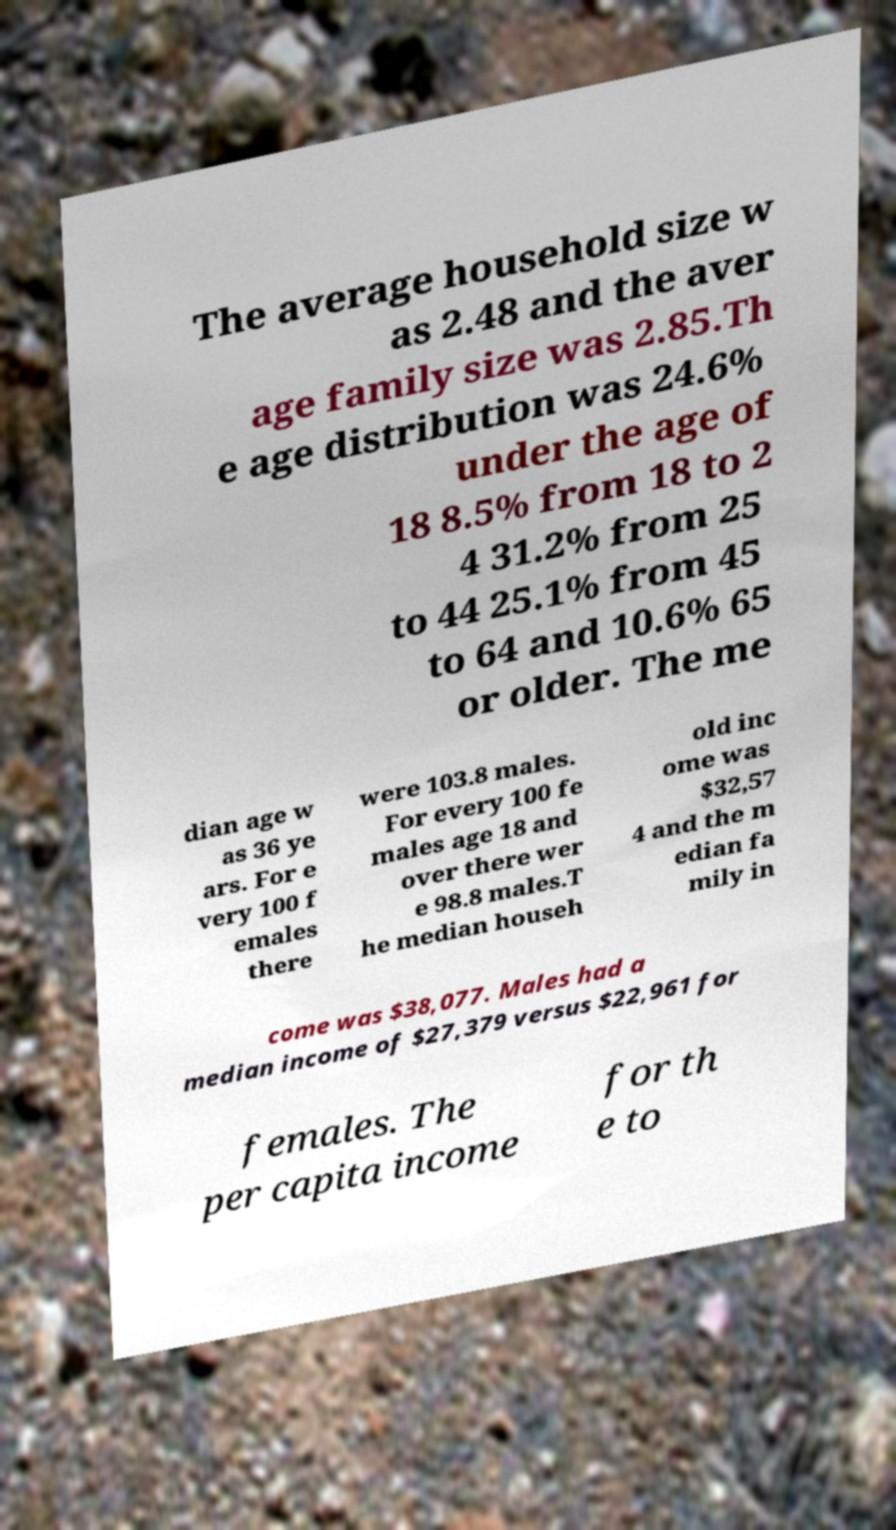Could you extract and type out the text from this image? The average household size w as 2.48 and the aver age family size was 2.85.Th e age distribution was 24.6% under the age of 18 8.5% from 18 to 2 4 31.2% from 25 to 44 25.1% from 45 to 64 and 10.6% 65 or older. The me dian age w as 36 ye ars. For e very 100 f emales there were 103.8 males. For every 100 fe males age 18 and over there wer e 98.8 males.T he median househ old inc ome was $32,57 4 and the m edian fa mily in come was $38,077. Males had a median income of $27,379 versus $22,961 for females. The per capita income for th e to 